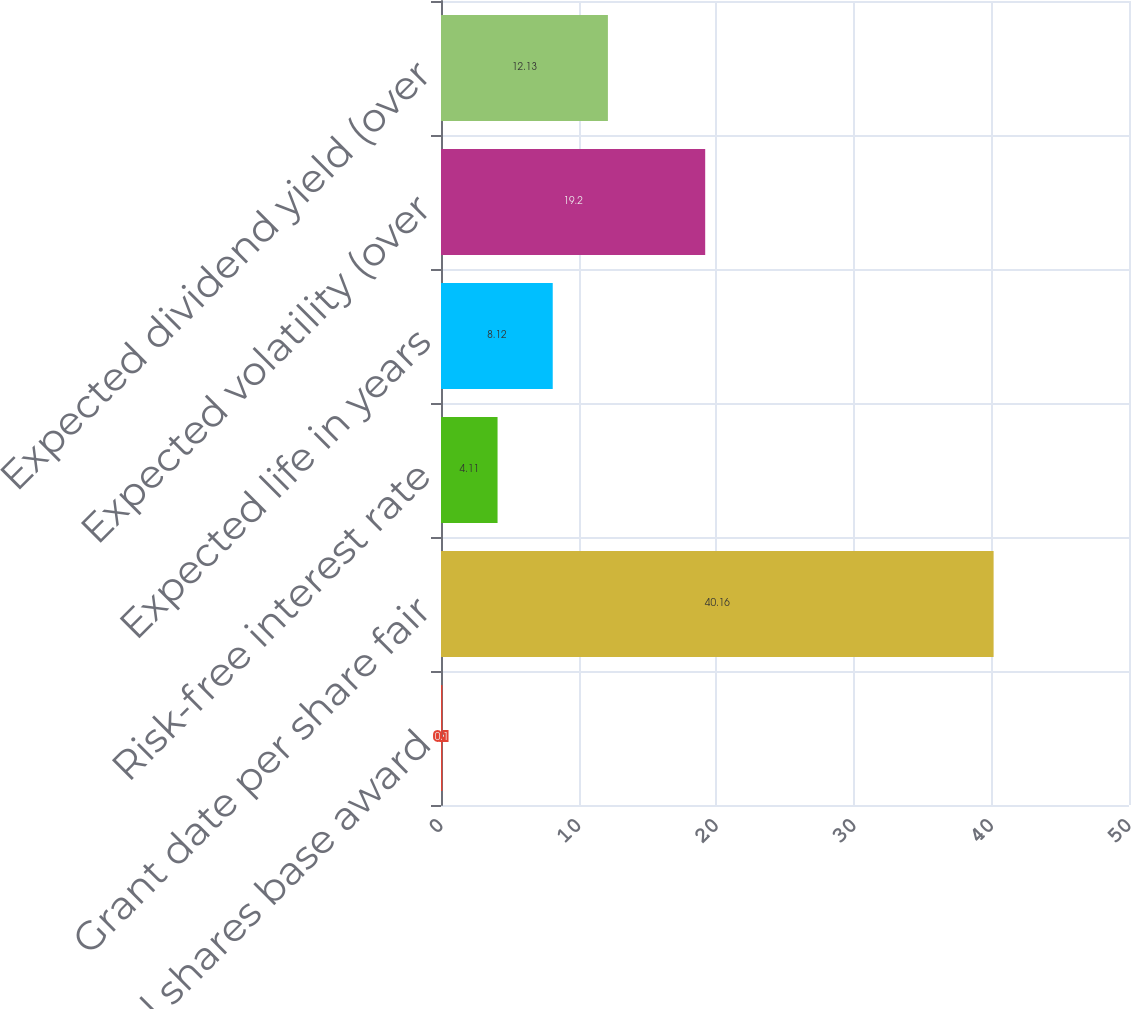<chart> <loc_0><loc_0><loc_500><loc_500><bar_chart><fcel>Total shares base award<fcel>Grant date per share fair<fcel>Risk-free interest rate<fcel>Expected life in years<fcel>Expected volatility (over<fcel>Expected dividend yield (over<nl><fcel>0.1<fcel>40.16<fcel>4.11<fcel>8.12<fcel>19.2<fcel>12.13<nl></chart> 